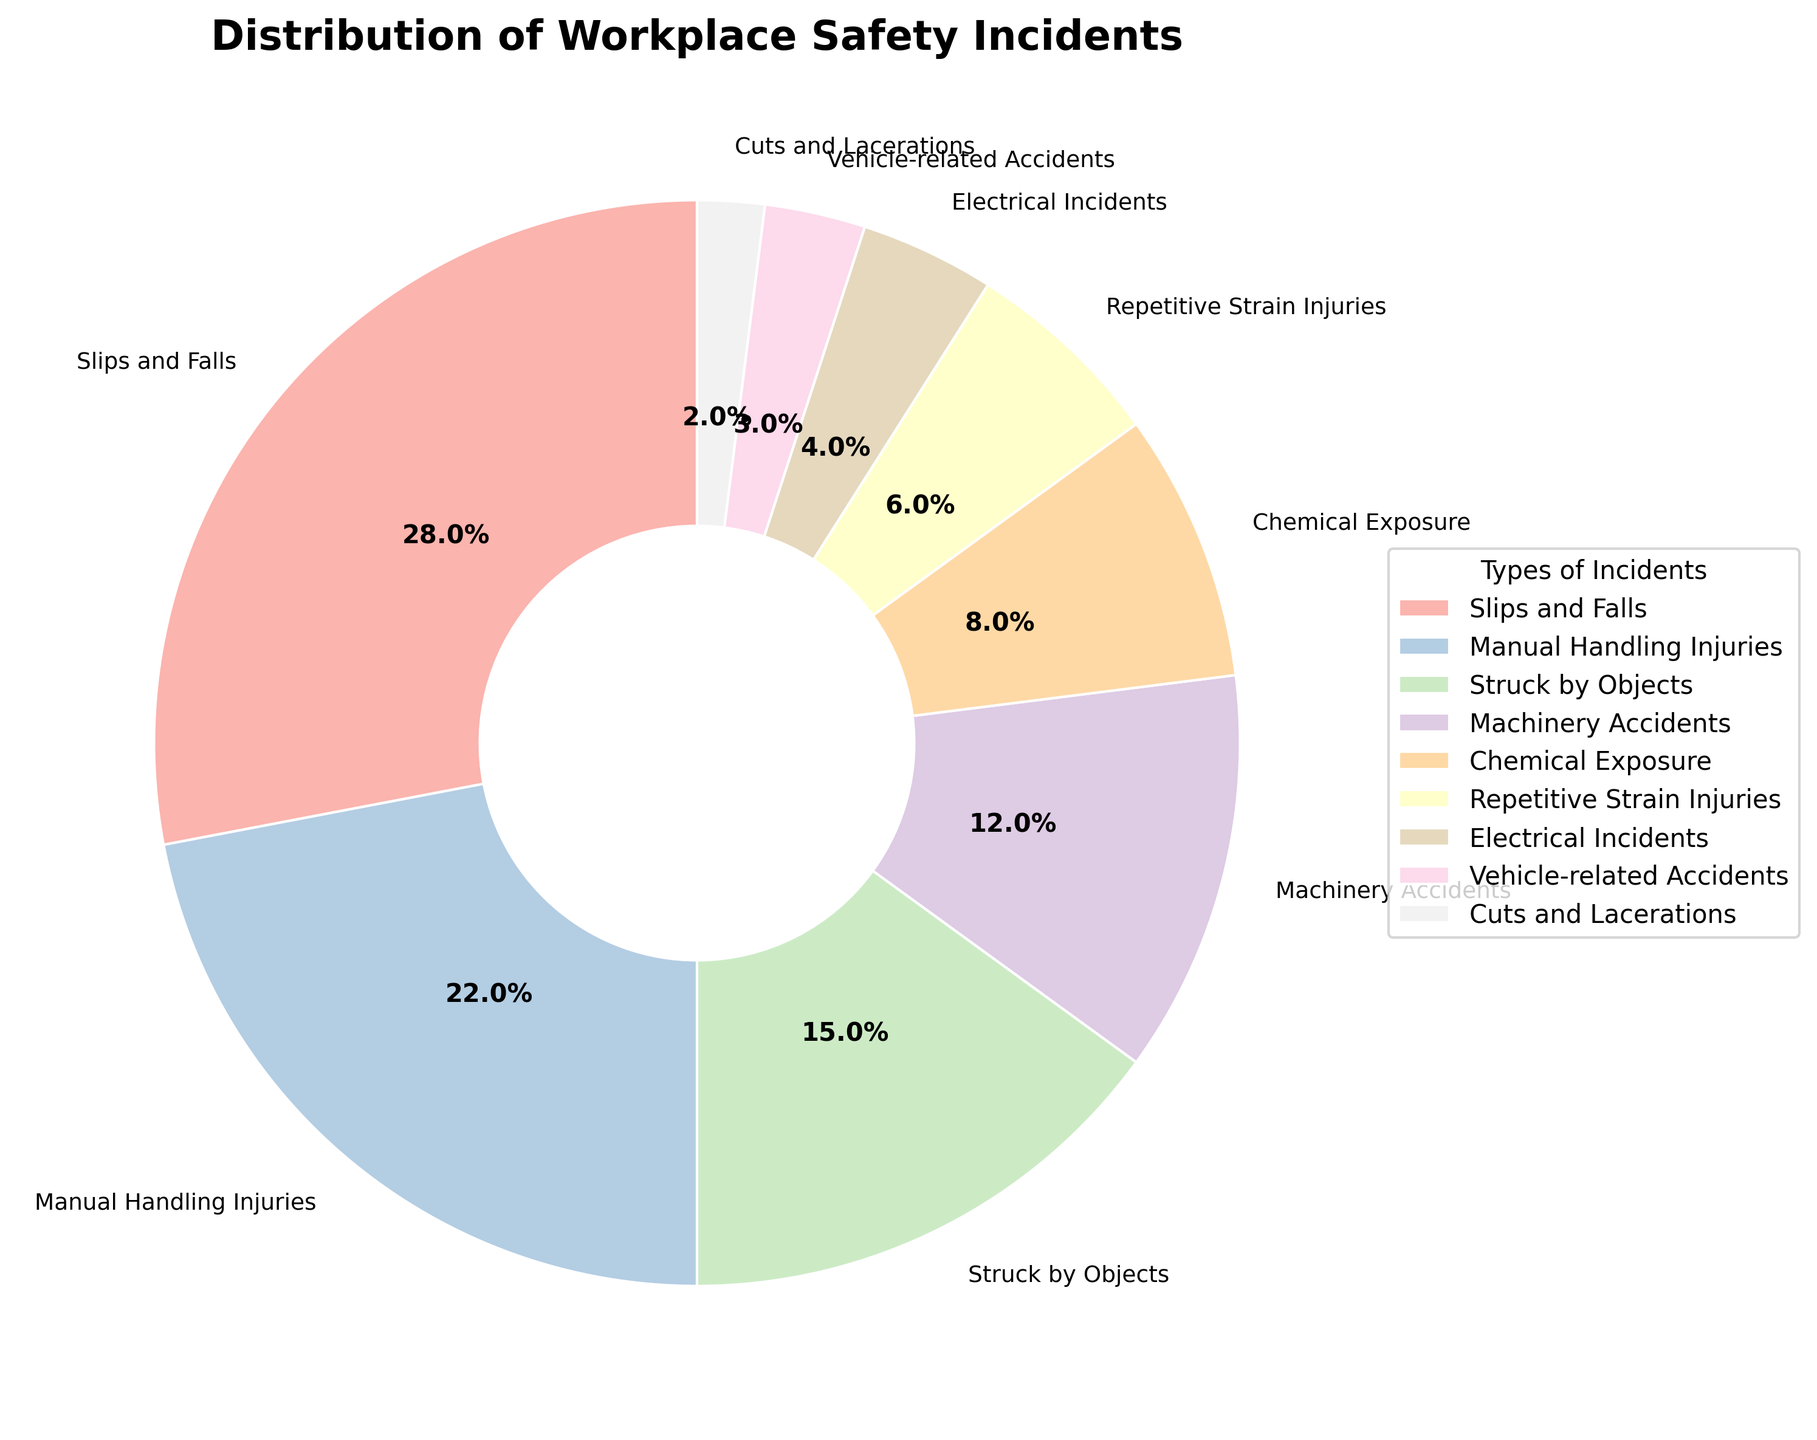What's the total percentage of incidents involving Slips and Falls and Manual Handling Injuries? To find the total percentage, add the percentages of Slips and Falls (28%) and Manual Handling Injuries (22%). So, 28 + 22 = 50%.
Answer: 50% Which type of incident accounts for the smallest percentage? The Pie Chart shows that Cuts and Lacerations have the smallest percentage at 2%.
Answer: Cuts and Lacerations How much larger is the percentage of Slips and Falls compared to Electrical Incidents? Subtract the percentage of Electrical Incidents (4%) from the percentage of Slips and Falls (28%). So, 28 - 4 = 24%.
Answer: 24% What are the types of incidents with less than 10% each? From the chart, the following types have less than 10% each: Chemical Exposure (8%), Repetitive Strain Injuries (6%), Electrical Incidents (4%), Vehicle-related Accidents (3%), and Cuts and Lacerations (2%).
Answer: Chemical Exposure, Repetitive Strain Injuries, Electrical Incidents, Vehicle-related Accidents, Cuts and Lacerations Which incidents together make up more than half of the total incidents? Slips and Falls (28%), Manual Handling Injuries (22%), and Struck by Objects (15%) sum up to 65%, which is more than half. Summing: 28 + 22 + 15 = 65%.
Answer: Slips and Falls, Manual Handling Injuries, and Struck by Objects Do Machinery Accidents account for more or less than 10% of the total incidents? According to the chart, Machinery Accidents account for 12%, which is more than 10%.
Answer: More What's the difference in percentage between the top two incident types? The top two incident types are Slips and Falls (28%) and Manual Handling Injuries (22%). The difference is 28 - 22 = 6%.
Answer: 6% Which type of incident appears in lightest color? Without exact color coding, the question relies on the labeling and general assumptions. Generally, the section representing Cuts and Lacerations (2%) typically appears with the lightest color for the least represented segment.
Answer: Cuts and Lacerations 